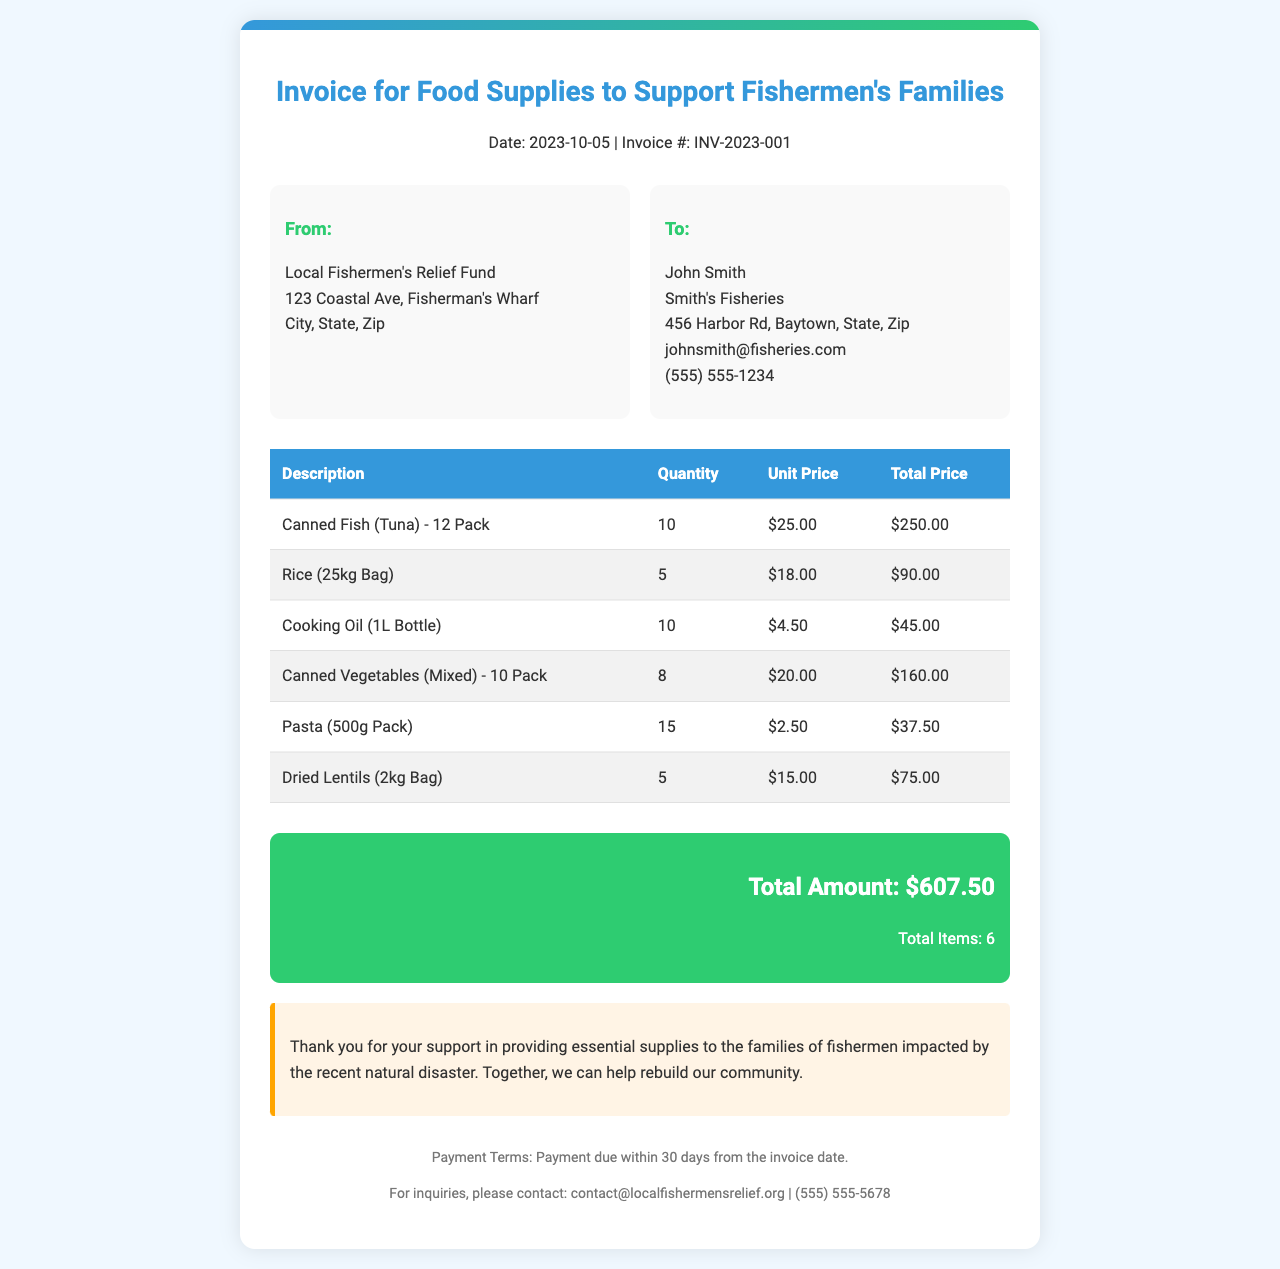What is the date of the invoice? The invoice date appears in the header section of the document.
Answer: 2023-10-05 Who is the recipient of the invoice? The invoice lists the recipient's name and contact details in the "To" section.
Answer: John Smith What is the total amount due on this invoice? The total amount due is found in the summary section of the document.
Answer: $607.50 How many Canned Fish (Tuna) packs were ordered? The quantity ordered can be found in the table listing the food supplies.
Answer: 10 What is the unit price of Rice (25kg Bag)? The unit price is detailed in the food supplies table.
Answer: $18.00 What is the total price of the Dried Lentils (2kg Bag)? The total price is calculated using the quantity and unit price in the supplies table.
Answer: $75.00 What are the payment terms stated in the document? The payment terms are specified in the footer of the invoice.
Answer: Payment due within 30 days How many items in total are listed on this invoice? The total number of items is mentioned in the summary section.
Answer: 6 What type of support does this invoice relate to? The type of support is indicated in the title of the invoice.
Answer: Food Supplies to Support Fishermen's Families 